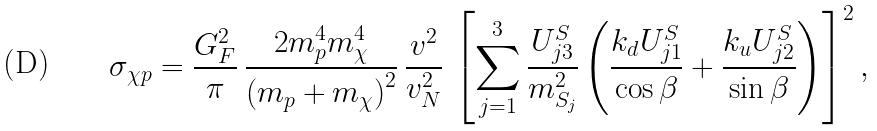Convert formula to latex. <formula><loc_0><loc_0><loc_500><loc_500>\sigma _ { \chi p } = \frac { G _ { F } ^ { 2 } } { \pi } \, \frac { 2 m _ { p } ^ { 4 } m _ { \chi } ^ { 4 } } { \left ( m _ { p } + m _ { \chi } \right ) ^ { 2 } } \, \frac { v ^ { 2 } } { v _ { N } ^ { 2 } } \, \left [ \sum _ { j = 1 } ^ { 3 } \frac { U ^ { S } _ { j 3 } } { m _ { S _ { j } } ^ { 2 } } \left ( \frac { k _ { d } U ^ { S } _ { j 1 } } { \cos \beta } + \frac { k _ { u } U ^ { S } _ { j 2 } } { \sin \beta } \right ) \right ] ^ { 2 } ,</formula> 